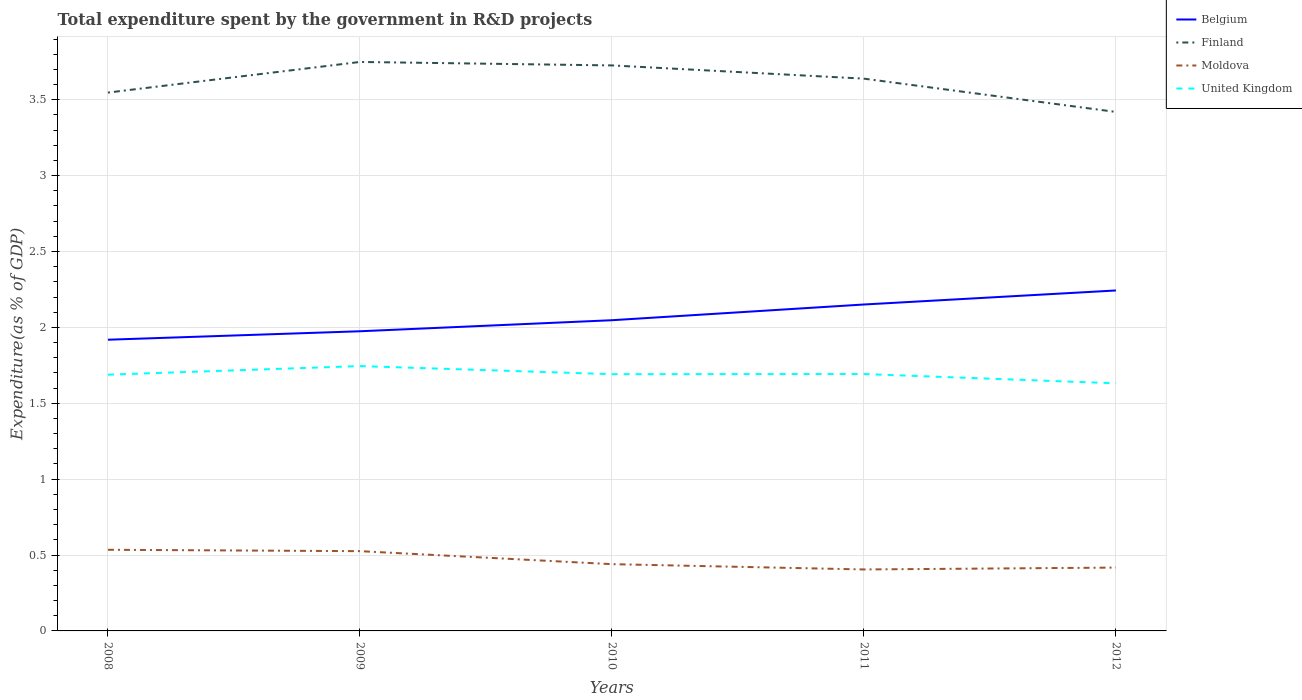How many different coloured lines are there?
Ensure brevity in your answer.  4. Across all years, what is the maximum total expenditure spent by the government in R&D projects in Moldova?
Keep it short and to the point. 0.4. What is the total total expenditure spent by the government in R&D projects in Belgium in the graph?
Offer a very short reply. -0.32. What is the difference between the highest and the second highest total expenditure spent by the government in R&D projects in United Kingdom?
Make the answer very short. 0.11. What is the difference between the highest and the lowest total expenditure spent by the government in R&D projects in Belgium?
Keep it short and to the point. 2. Does the graph contain grids?
Offer a terse response. Yes. Where does the legend appear in the graph?
Make the answer very short. Top right. How many legend labels are there?
Keep it short and to the point. 4. How are the legend labels stacked?
Offer a very short reply. Vertical. What is the title of the graph?
Your response must be concise. Total expenditure spent by the government in R&D projects. Does "Nigeria" appear as one of the legend labels in the graph?
Keep it short and to the point. No. What is the label or title of the Y-axis?
Provide a short and direct response. Expenditure(as % of GDP). What is the Expenditure(as % of GDP) of Belgium in 2008?
Your response must be concise. 1.92. What is the Expenditure(as % of GDP) of Finland in 2008?
Your answer should be compact. 3.55. What is the Expenditure(as % of GDP) of Moldova in 2008?
Ensure brevity in your answer.  0.53. What is the Expenditure(as % of GDP) of United Kingdom in 2008?
Make the answer very short. 1.69. What is the Expenditure(as % of GDP) of Belgium in 2009?
Your response must be concise. 1.97. What is the Expenditure(as % of GDP) of Finland in 2009?
Your answer should be very brief. 3.75. What is the Expenditure(as % of GDP) in Moldova in 2009?
Ensure brevity in your answer.  0.53. What is the Expenditure(as % of GDP) of United Kingdom in 2009?
Make the answer very short. 1.75. What is the Expenditure(as % of GDP) in Belgium in 2010?
Provide a succinct answer. 2.05. What is the Expenditure(as % of GDP) in Finland in 2010?
Keep it short and to the point. 3.73. What is the Expenditure(as % of GDP) in Moldova in 2010?
Make the answer very short. 0.44. What is the Expenditure(as % of GDP) in United Kingdom in 2010?
Ensure brevity in your answer.  1.69. What is the Expenditure(as % of GDP) of Belgium in 2011?
Offer a very short reply. 2.15. What is the Expenditure(as % of GDP) in Finland in 2011?
Provide a succinct answer. 3.64. What is the Expenditure(as % of GDP) in Moldova in 2011?
Your answer should be very brief. 0.4. What is the Expenditure(as % of GDP) in United Kingdom in 2011?
Your answer should be compact. 1.69. What is the Expenditure(as % of GDP) of Belgium in 2012?
Ensure brevity in your answer.  2.24. What is the Expenditure(as % of GDP) of Finland in 2012?
Keep it short and to the point. 3.42. What is the Expenditure(as % of GDP) in Moldova in 2012?
Provide a succinct answer. 0.42. What is the Expenditure(as % of GDP) in United Kingdom in 2012?
Your answer should be very brief. 1.63. Across all years, what is the maximum Expenditure(as % of GDP) in Belgium?
Offer a very short reply. 2.24. Across all years, what is the maximum Expenditure(as % of GDP) of Finland?
Your answer should be compact. 3.75. Across all years, what is the maximum Expenditure(as % of GDP) in Moldova?
Give a very brief answer. 0.53. Across all years, what is the maximum Expenditure(as % of GDP) in United Kingdom?
Provide a short and direct response. 1.75. Across all years, what is the minimum Expenditure(as % of GDP) of Belgium?
Ensure brevity in your answer.  1.92. Across all years, what is the minimum Expenditure(as % of GDP) of Finland?
Keep it short and to the point. 3.42. Across all years, what is the minimum Expenditure(as % of GDP) of Moldova?
Provide a short and direct response. 0.4. Across all years, what is the minimum Expenditure(as % of GDP) in United Kingdom?
Provide a succinct answer. 1.63. What is the total Expenditure(as % of GDP) of Belgium in the graph?
Your response must be concise. 10.33. What is the total Expenditure(as % of GDP) of Finland in the graph?
Make the answer very short. 18.08. What is the total Expenditure(as % of GDP) of Moldova in the graph?
Offer a terse response. 2.32. What is the total Expenditure(as % of GDP) in United Kingdom in the graph?
Your answer should be very brief. 8.45. What is the difference between the Expenditure(as % of GDP) of Belgium in 2008 and that in 2009?
Give a very brief answer. -0.06. What is the difference between the Expenditure(as % of GDP) of Finland in 2008 and that in 2009?
Give a very brief answer. -0.2. What is the difference between the Expenditure(as % of GDP) in Moldova in 2008 and that in 2009?
Keep it short and to the point. 0.01. What is the difference between the Expenditure(as % of GDP) of United Kingdom in 2008 and that in 2009?
Provide a short and direct response. -0.06. What is the difference between the Expenditure(as % of GDP) of Belgium in 2008 and that in 2010?
Make the answer very short. -0.13. What is the difference between the Expenditure(as % of GDP) of Finland in 2008 and that in 2010?
Provide a short and direct response. -0.18. What is the difference between the Expenditure(as % of GDP) of Moldova in 2008 and that in 2010?
Provide a short and direct response. 0.09. What is the difference between the Expenditure(as % of GDP) of United Kingdom in 2008 and that in 2010?
Provide a succinct answer. -0. What is the difference between the Expenditure(as % of GDP) of Belgium in 2008 and that in 2011?
Offer a terse response. -0.23. What is the difference between the Expenditure(as % of GDP) in Finland in 2008 and that in 2011?
Keep it short and to the point. -0.09. What is the difference between the Expenditure(as % of GDP) of Moldova in 2008 and that in 2011?
Your answer should be compact. 0.13. What is the difference between the Expenditure(as % of GDP) in United Kingdom in 2008 and that in 2011?
Provide a succinct answer. -0. What is the difference between the Expenditure(as % of GDP) of Belgium in 2008 and that in 2012?
Offer a terse response. -0.32. What is the difference between the Expenditure(as % of GDP) of Finland in 2008 and that in 2012?
Your answer should be compact. 0.13. What is the difference between the Expenditure(as % of GDP) of Moldova in 2008 and that in 2012?
Offer a very short reply. 0.12. What is the difference between the Expenditure(as % of GDP) in United Kingdom in 2008 and that in 2012?
Provide a short and direct response. 0.06. What is the difference between the Expenditure(as % of GDP) of Belgium in 2009 and that in 2010?
Provide a short and direct response. -0.07. What is the difference between the Expenditure(as % of GDP) in Finland in 2009 and that in 2010?
Provide a short and direct response. 0.02. What is the difference between the Expenditure(as % of GDP) of Moldova in 2009 and that in 2010?
Provide a short and direct response. 0.09. What is the difference between the Expenditure(as % of GDP) in United Kingdom in 2009 and that in 2010?
Provide a succinct answer. 0.05. What is the difference between the Expenditure(as % of GDP) in Belgium in 2009 and that in 2011?
Provide a succinct answer. -0.18. What is the difference between the Expenditure(as % of GDP) of Finland in 2009 and that in 2011?
Offer a terse response. 0.11. What is the difference between the Expenditure(as % of GDP) in Moldova in 2009 and that in 2011?
Provide a short and direct response. 0.12. What is the difference between the Expenditure(as % of GDP) of United Kingdom in 2009 and that in 2011?
Your answer should be compact. 0.05. What is the difference between the Expenditure(as % of GDP) of Belgium in 2009 and that in 2012?
Keep it short and to the point. -0.27. What is the difference between the Expenditure(as % of GDP) of Finland in 2009 and that in 2012?
Give a very brief answer. 0.33. What is the difference between the Expenditure(as % of GDP) of Moldova in 2009 and that in 2012?
Give a very brief answer. 0.11. What is the difference between the Expenditure(as % of GDP) in United Kingdom in 2009 and that in 2012?
Provide a succinct answer. 0.11. What is the difference between the Expenditure(as % of GDP) in Belgium in 2010 and that in 2011?
Your response must be concise. -0.1. What is the difference between the Expenditure(as % of GDP) in Finland in 2010 and that in 2011?
Provide a succinct answer. 0.09. What is the difference between the Expenditure(as % of GDP) in Moldova in 2010 and that in 2011?
Offer a very short reply. 0.03. What is the difference between the Expenditure(as % of GDP) in United Kingdom in 2010 and that in 2011?
Ensure brevity in your answer.  -0. What is the difference between the Expenditure(as % of GDP) in Belgium in 2010 and that in 2012?
Offer a very short reply. -0.2. What is the difference between the Expenditure(as % of GDP) of Finland in 2010 and that in 2012?
Provide a succinct answer. 0.31. What is the difference between the Expenditure(as % of GDP) of Moldova in 2010 and that in 2012?
Your response must be concise. 0.02. What is the difference between the Expenditure(as % of GDP) of United Kingdom in 2010 and that in 2012?
Keep it short and to the point. 0.06. What is the difference between the Expenditure(as % of GDP) of Belgium in 2011 and that in 2012?
Give a very brief answer. -0.09. What is the difference between the Expenditure(as % of GDP) in Finland in 2011 and that in 2012?
Provide a short and direct response. 0.22. What is the difference between the Expenditure(as % of GDP) in Moldova in 2011 and that in 2012?
Keep it short and to the point. -0.01. What is the difference between the Expenditure(as % of GDP) in United Kingdom in 2011 and that in 2012?
Your answer should be compact. 0.06. What is the difference between the Expenditure(as % of GDP) of Belgium in 2008 and the Expenditure(as % of GDP) of Finland in 2009?
Your answer should be compact. -1.83. What is the difference between the Expenditure(as % of GDP) of Belgium in 2008 and the Expenditure(as % of GDP) of Moldova in 2009?
Offer a very short reply. 1.39. What is the difference between the Expenditure(as % of GDP) of Belgium in 2008 and the Expenditure(as % of GDP) of United Kingdom in 2009?
Provide a succinct answer. 0.17. What is the difference between the Expenditure(as % of GDP) of Finland in 2008 and the Expenditure(as % of GDP) of Moldova in 2009?
Make the answer very short. 3.02. What is the difference between the Expenditure(as % of GDP) in Finland in 2008 and the Expenditure(as % of GDP) in United Kingdom in 2009?
Your answer should be compact. 1.8. What is the difference between the Expenditure(as % of GDP) of Moldova in 2008 and the Expenditure(as % of GDP) of United Kingdom in 2009?
Your answer should be compact. -1.21. What is the difference between the Expenditure(as % of GDP) of Belgium in 2008 and the Expenditure(as % of GDP) of Finland in 2010?
Offer a terse response. -1.81. What is the difference between the Expenditure(as % of GDP) of Belgium in 2008 and the Expenditure(as % of GDP) of Moldova in 2010?
Provide a succinct answer. 1.48. What is the difference between the Expenditure(as % of GDP) in Belgium in 2008 and the Expenditure(as % of GDP) in United Kingdom in 2010?
Offer a terse response. 0.23. What is the difference between the Expenditure(as % of GDP) of Finland in 2008 and the Expenditure(as % of GDP) of Moldova in 2010?
Provide a succinct answer. 3.11. What is the difference between the Expenditure(as % of GDP) in Finland in 2008 and the Expenditure(as % of GDP) in United Kingdom in 2010?
Offer a very short reply. 1.86. What is the difference between the Expenditure(as % of GDP) of Moldova in 2008 and the Expenditure(as % of GDP) of United Kingdom in 2010?
Provide a short and direct response. -1.16. What is the difference between the Expenditure(as % of GDP) of Belgium in 2008 and the Expenditure(as % of GDP) of Finland in 2011?
Your response must be concise. -1.72. What is the difference between the Expenditure(as % of GDP) of Belgium in 2008 and the Expenditure(as % of GDP) of Moldova in 2011?
Ensure brevity in your answer.  1.51. What is the difference between the Expenditure(as % of GDP) of Belgium in 2008 and the Expenditure(as % of GDP) of United Kingdom in 2011?
Offer a terse response. 0.23. What is the difference between the Expenditure(as % of GDP) of Finland in 2008 and the Expenditure(as % of GDP) of Moldova in 2011?
Keep it short and to the point. 3.14. What is the difference between the Expenditure(as % of GDP) of Finland in 2008 and the Expenditure(as % of GDP) of United Kingdom in 2011?
Offer a terse response. 1.85. What is the difference between the Expenditure(as % of GDP) of Moldova in 2008 and the Expenditure(as % of GDP) of United Kingdom in 2011?
Make the answer very short. -1.16. What is the difference between the Expenditure(as % of GDP) of Belgium in 2008 and the Expenditure(as % of GDP) of Finland in 2012?
Provide a short and direct response. -1.5. What is the difference between the Expenditure(as % of GDP) of Belgium in 2008 and the Expenditure(as % of GDP) of Moldova in 2012?
Your answer should be very brief. 1.5. What is the difference between the Expenditure(as % of GDP) in Belgium in 2008 and the Expenditure(as % of GDP) in United Kingdom in 2012?
Provide a short and direct response. 0.29. What is the difference between the Expenditure(as % of GDP) in Finland in 2008 and the Expenditure(as % of GDP) in Moldova in 2012?
Keep it short and to the point. 3.13. What is the difference between the Expenditure(as % of GDP) in Finland in 2008 and the Expenditure(as % of GDP) in United Kingdom in 2012?
Keep it short and to the point. 1.92. What is the difference between the Expenditure(as % of GDP) of Moldova in 2008 and the Expenditure(as % of GDP) of United Kingdom in 2012?
Your answer should be very brief. -1.1. What is the difference between the Expenditure(as % of GDP) of Belgium in 2009 and the Expenditure(as % of GDP) of Finland in 2010?
Your answer should be very brief. -1.75. What is the difference between the Expenditure(as % of GDP) in Belgium in 2009 and the Expenditure(as % of GDP) in Moldova in 2010?
Your answer should be very brief. 1.53. What is the difference between the Expenditure(as % of GDP) in Belgium in 2009 and the Expenditure(as % of GDP) in United Kingdom in 2010?
Your answer should be very brief. 0.28. What is the difference between the Expenditure(as % of GDP) of Finland in 2009 and the Expenditure(as % of GDP) of Moldova in 2010?
Your answer should be very brief. 3.31. What is the difference between the Expenditure(as % of GDP) in Finland in 2009 and the Expenditure(as % of GDP) in United Kingdom in 2010?
Offer a very short reply. 2.06. What is the difference between the Expenditure(as % of GDP) of Moldova in 2009 and the Expenditure(as % of GDP) of United Kingdom in 2010?
Provide a short and direct response. -1.17. What is the difference between the Expenditure(as % of GDP) of Belgium in 2009 and the Expenditure(as % of GDP) of Finland in 2011?
Your response must be concise. -1.66. What is the difference between the Expenditure(as % of GDP) of Belgium in 2009 and the Expenditure(as % of GDP) of Moldova in 2011?
Ensure brevity in your answer.  1.57. What is the difference between the Expenditure(as % of GDP) of Belgium in 2009 and the Expenditure(as % of GDP) of United Kingdom in 2011?
Your answer should be very brief. 0.28. What is the difference between the Expenditure(as % of GDP) in Finland in 2009 and the Expenditure(as % of GDP) in Moldova in 2011?
Make the answer very short. 3.34. What is the difference between the Expenditure(as % of GDP) of Finland in 2009 and the Expenditure(as % of GDP) of United Kingdom in 2011?
Your response must be concise. 2.06. What is the difference between the Expenditure(as % of GDP) of Moldova in 2009 and the Expenditure(as % of GDP) of United Kingdom in 2011?
Provide a short and direct response. -1.17. What is the difference between the Expenditure(as % of GDP) of Belgium in 2009 and the Expenditure(as % of GDP) of Finland in 2012?
Offer a terse response. -1.45. What is the difference between the Expenditure(as % of GDP) of Belgium in 2009 and the Expenditure(as % of GDP) of Moldova in 2012?
Provide a succinct answer. 1.56. What is the difference between the Expenditure(as % of GDP) of Belgium in 2009 and the Expenditure(as % of GDP) of United Kingdom in 2012?
Ensure brevity in your answer.  0.34. What is the difference between the Expenditure(as % of GDP) of Finland in 2009 and the Expenditure(as % of GDP) of Moldova in 2012?
Ensure brevity in your answer.  3.33. What is the difference between the Expenditure(as % of GDP) in Finland in 2009 and the Expenditure(as % of GDP) in United Kingdom in 2012?
Provide a short and direct response. 2.12. What is the difference between the Expenditure(as % of GDP) of Moldova in 2009 and the Expenditure(as % of GDP) of United Kingdom in 2012?
Your response must be concise. -1.11. What is the difference between the Expenditure(as % of GDP) of Belgium in 2010 and the Expenditure(as % of GDP) of Finland in 2011?
Offer a very short reply. -1.59. What is the difference between the Expenditure(as % of GDP) of Belgium in 2010 and the Expenditure(as % of GDP) of Moldova in 2011?
Keep it short and to the point. 1.64. What is the difference between the Expenditure(as % of GDP) of Belgium in 2010 and the Expenditure(as % of GDP) of United Kingdom in 2011?
Give a very brief answer. 0.35. What is the difference between the Expenditure(as % of GDP) of Finland in 2010 and the Expenditure(as % of GDP) of Moldova in 2011?
Provide a short and direct response. 3.32. What is the difference between the Expenditure(as % of GDP) of Finland in 2010 and the Expenditure(as % of GDP) of United Kingdom in 2011?
Give a very brief answer. 2.03. What is the difference between the Expenditure(as % of GDP) of Moldova in 2010 and the Expenditure(as % of GDP) of United Kingdom in 2011?
Ensure brevity in your answer.  -1.25. What is the difference between the Expenditure(as % of GDP) in Belgium in 2010 and the Expenditure(as % of GDP) in Finland in 2012?
Your answer should be compact. -1.37. What is the difference between the Expenditure(as % of GDP) in Belgium in 2010 and the Expenditure(as % of GDP) in Moldova in 2012?
Your response must be concise. 1.63. What is the difference between the Expenditure(as % of GDP) of Belgium in 2010 and the Expenditure(as % of GDP) of United Kingdom in 2012?
Ensure brevity in your answer.  0.42. What is the difference between the Expenditure(as % of GDP) in Finland in 2010 and the Expenditure(as % of GDP) in Moldova in 2012?
Offer a terse response. 3.31. What is the difference between the Expenditure(as % of GDP) in Finland in 2010 and the Expenditure(as % of GDP) in United Kingdom in 2012?
Your response must be concise. 2.09. What is the difference between the Expenditure(as % of GDP) of Moldova in 2010 and the Expenditure(as % of GDP) of United Kingdom in 2012?
Offer a very short reply. -1.19. What is the difference between the Expenditure(as % of GDP) of Belgium in 2011 and the Expenditure(as % of GDP) of Finland in 2012?
Your answer should be compact. -1.27. What is the difference between the Expenditure(as % of GDP) in Belgium in 2011 and the Expenditure(as % of GDP) in Moldova in 2012?
Your response must be concise. 1.73. What is the difference between the Expenditure(as % of GDP) of Belgium in 2011 and the Expenditure(as % of GDP) of United Kingdom in 2012?
Your response must be concise. 0.52. What is the difference between the Expenditure(as % of GDP) of Finland in 2011 and the Expenditure(as % of GDP) of Moldova in 2012?
Provide a succinct answer. 3.22. What is the difference between the Expenditure(as % of GDP) in Finland in 2011 and the Expenditure(as % of GDP) in United Kingdom in 2012?
Give a very brief answer. 2.01. What is the difference between the Expenditure(as % of GDP) of Moldova in 2011 and the Expenditure(as % of GDP) of United Kingdom in 2012?
Your answer should be very brief. -1.23. What is the average Expenditure(as % of GDP) of Belgium per year?
Your response must be concise. 2.07. What is the average Expenditure(as % of GDP) in Finland per year?
Give a very brief answer. 3.62. What is the average Expenditure(as % of GDP) in Moldova per year?
Your response must be concise. 0.46. What is the average Expenditure(as % of GDP) in United Kingdom per year?
Make the answer very short. 1.69. In the year 2008, what is the difference between the Expenditure(as % of GDP) of Belgium and Expenditure(as % of GDP) of Finland?
Ensure brevity in your answer.  -1.63. In the year 2008, what is the difference between the Expenditure(as % of GDP) in Belgium and Expenditure(as % of GDP) in Moldova?
Your answer should be compact. 1.38. In the year 2008, what is the difference between the Expenditure(as % of GDP) in Belgium and Expenditure(as % of GDP) in United Kingdom?
Your answer should be very brief. 0.23. In the year 2008, what is the difference between the Expenditure(as % of GDP) of Finland and Expenditure(as % of GDP) of Moldova?
Your answer should be very brief. 3.01. In the year 2008, what is the difference between the Expenditure(as % of GDP) in Finland and Expenditure(as % of GDP) in United Kingdom?
Your answer should be compact. 1.86. In the year 2008, what is the difference between the Expenditure(as % of GDP) in Moldova and Expenditure(as % of GDP) in United Kingdom?
Provide a short and direct response. -1.15. In the year 2009, what is the difference between the Expenditure(as % of GDP) in Belgium and Expenditure(as % of GDP) in Finland?
Ensure brevity in your answer.  -1.77. In the year 2009, what is the difference between the Expenditure(as % of GDP) of Belgium and Expenditure(as % of GDP) of Moldova?
Your answer should be compact. 1.45. In the year 2009, what is the difference between the Expenditure(as % of GDP) in Belgium and Expenditure(as % of GDP) in United Kingdom?
Offer a very short reply. 0.23. In the year 2009, what is the difference between the Expenditure(as % of GDP) of Finland and Expenditure(as % of GDP) of Moldova?
Keep it short and to the point. 3.22. In the year 2009, what is the difference between the Expenditure(as % of GDP) of Finland and Expenditure(as % of GDP) of United Kingdom?
Your answer should be very brief. 2. In the year 2009, what is the difference between the Expenditure(as % of GDP) in Moldova and Expenditure(as % of GDP) in United Kingdom?
Provide a succinct answer. -1.22. In the year 2010, what is the difference between the Expenditure(as % of GDP) in Belgium and Expenditure(as % of GDP) in Finland?
Your response must be concise. -1.68. In the year 2010, what is the difference between the Expenditure(as % of GDP) of Belgium and Expenditure(as % of GDP) of Moldova?
Your answer should be compact. 1.61. In the year 2010, what is the difference between the Expenditure(as % of GDP) in Belgium and Expenditure(as % of GDP) in United Kingdom?
Offer a terse response. 0.36. In the year 2010, what is the difference between the Expenditure(as % of GDP) of Finland and Expenditure(as % of GDP) of Moldova?
Your response must be concise. 3.29. In the year 2010, what is the difference between the Expenditure(as % of GDP) in Finland and Expenditure(as % of GDP) in United Kingdom?
Your answer should be very brief. 2.03. In the year 2010, what is the difference between the Expenditure(as % of GDP) in Moldova and Expenditure(as % of GDP) in United Kingdom?
Your answer should be very brief. -1.25. In the year 2011, what is the difference between the Expenditure(as % of GDP) in Belgium and Expenditure(as % of GDP) in Finland?
Keep it short and to the point. -1.49. In the year 2011, what is the difference between the Expenditure(as % of GDP) in Belgium and Expenditure(as % of GDP) in Moldova?
Ensure brevity in your answer.  1.75. In the year 2011, what is the difference between the Expenditure(as % of GDP) in Belgium and Expenditure(as % of GDP) in United Kingdom?
Provide a short and direct response. 0.46. In the year 2011, what is the difference between the Expenditure(as % of GDP) of Finland and Expenditure(as % of GDP) of Moldova?
Your response must be concise. 3.23. In the year 2011, what is the difference between the Expenditure(as % of GDP) of Finland and Expenditure(as % of GDP) of United Kingdom?
Keep it short and to the point. 1.95. In the year 2011, what is the difference between the Expenditure(as % of GDP) of Moldova and Expenditure(as % of GDP) of United Kingdom?
Offer a very short reply. -1.29. In the year 2012, what is the difference between the Expenditure(as % of GDP) of Belgium and Expenditure(as % of GDP) of Finland?
Your answer should be compact. -1.18. In the year 2012, what is the difference between the Expenditure(as % of GDP) in Belgium and Expenditure(as % of GDP) in Moldova?
Your response must be concise. 1.83. In the year 2012, what is the difference between the Expenditure(as % of GDP) in Belgium and Expenditure(as % of GDP) in United Kingdom?
Offer a terse response. 0.61. In the year 2012, what is the difference between the Expenditure(as % of GDP) in Finland and Expenditure(as % of GDP) in Moldova?
Give a very brief answer. 3. In the year 2012, what is the difference between the Expenditure(as % of GDP) in Finland and Expenditure(as % of GDP) in United Kingdom?
Your answer should be very brief. 1.79. In the year 2012, what is the difference between the Expenditure(as % of GDP) in Moldova and Expenditure(as % of GDP) in United Kingdom?
Make the answer very short. -1.21. What is the ratio of the Expenditure(as % of GDP) in Belgium in 2008 to that in 2009?
Provide a short and direct response. 0.97. What is the ratio of the Expenditure(as % of GDP) of Finland in 2008 to that in 2009?
Provide a short and direct response. 0.95. What is the ratio of the Expenditure(as % of GDP) in Moldova in 2008 to that in 2009?
Offer a very short reply. 1.02. What is the ratio of the Expenditure(as % of GDP) of United Kingdom in 2008 to that in 2009?
Provide a short and direct response. 0.97. What is the ratio of the Expenditure(as % of GDP) of Belgium in 2008 to that in 2010?
Your answer should be very brief. 0.94. What is the ratio of the Expenditure(as % of GDP) of Moldova in 2008 to that in 2010?
Offer a very short reply. 1.22. What is the ratio of the Expenditure(as % of GDP) of Belgium in 2008 to that in 2011?
Offer a very short reply. 0.89. What is the ratio of the Expenditure(as % of GDP) in Finland in 2008 to that in 2011?
Your response must be concise. 0.97. What is the ratio of the Expenditure(as % of GDP) in Moldova in 2008 to that in 2011?
Ensure brevity in your answer.  1.32. What is the ratio of the Expenditure(as % of GDP) in Belgium in 2008 to that in 2012?
Your response must be concise. 0.86. What is the ratio of the Expenditure(as % of GDP) of Finland in 2008 to that in 2012?
Give a very brief answer. 1.04. What is the ratio of the Expenditure(as % of GDP) in Moldova in 2008 to that in 2012?
Provide a short and direct response. 1.28. What is the ratio of the Expenditure(as % of GDP) of United Kingdom in 2008 to that in 2012?
Keep it short and to the point. 1.03. What is the ratio of the Expenditure(as % of GDP) of Belgium in 2009 to that in 2010?
Offer a terse response. 0.96. What is the ratio of the Expenditure(as % of GDP) in Moldova in 2009 to that in 2010?
Keep it short and to the point. 1.19. What is the ratio of the Expenditure(as % of GDP) of United Kingdom in 2009 to that in 2010?
Your answer should be compact. 1.03. What is the ratio of the Expenditure(as % of GDP) in Belgium in 2009 to that in 2011?
Give a very brief answer. 0.92. What is the ratio of the Expenditure(as % of GDP) of Finland in 2009 to that in 2011?
Offer a terse response. 1.03. What is the ratio of the Expenditure(as % of GDP) of Moldova in 2009 to that in 2011?
Offer a very short reply. 1.3. What is the ratio of the Expenditure(as % of GDP) of United Kingdom in 2009 to that in 2011?
Your answer should be compact. 1.03. What is the ratio of the Expenditure(as % of GDP) of Belgium in 2009 to that in 2012?
Make the answer very short. 0.88. What is the ratio of the Expenditure(as % of GDP) in Finland in 2009 to that in 2012?
Provide a succinct answer. 1.1. What is the ratio of the Expenditure(as % of GDP) in Moldova in 2009 to that in 2012?
Make the answer very short. 1.26. What is the ratio of the Expenditure(as % of GDP) in United Kingdom in 2009 to that in 2012?
Provide a short and direct response. 1.07. What is the ratio of the Expenditure(as % of GDP) of Belgium in 2010 to that in 2011?
Your answer should be compact. 0.95. What is the ratio of the Expenditure(as % of GDP) in Moldova in 2010 to that in 2011?
Give a very brief answer. 1.09. What is the ratio of the Expenditure(as % of GDP) of Belgium in 2010 to that in 2012?
Your answer should be compact. 0.91. What is the ratio of the Expenditure(as % of GDP) in Finland in 2010 to that in 2012?
Offer a terse response. 1.09. What is the ratio of the Expenditure(as % of GDP) of Moldova in 2010 to that in 2012?
Offer a very short reply. 1.05. What is the ratio of the Expenditure(as % of GDP) of United Kingdom in 2010 to that in 2012?
Keep it short and to the point. 1.04. What is the ratio of the Expenditure(as % of GDP) of Belgium in 2011 to that in 2012?
Your answer should be very brief. 0.96. What is the ratio of the Expenditure(as % of GDP) in Finland in 2011 to that in 2012?
Your response must be concise. 1.06. What is the ratio of the Expenditure(as % of GDP) of Moldova in 2011 to that in 2012?
Ensure brevity in your answer.  0.97. What is the ratio of the Expenditure(as % of GDP) of United Kingdom in 2011 to that in 2012?
Your answer should be compact. 1.04. What is the difference between the highest and the second highest Expenditure(as % of GDP) in Belgium?
Your answer should be very brief. 0.09. What is the difference between the highest and the second highest Expenditure(as % of GDP) in Finland?
Provide a short and direct response. 0.02. What is the difference between the highest and the second highest Expenditure(as % of GDP) in Moldova?
Keep it short and to the point. 0.01. What is the difference between the highest and the second highest Expenditure(as % of GDP) of United Kingdom?
Ensure brevity in your answer.  0.05. What is the difference between the highest and the lowest Expenditure(as % of GDP) of Belgium?
Your response must be concise. 0.32. What is the difference between the highest and the lowest Expenditure(as % of GDP) in Finland?
Provide a succinct answer. 0.33. What is the difference between the highest and the lowest Expenditure(as % of GDP) in Moldova?
Give a very brief answer. 0.13. What is the difference between the highest and the lowest Expenditure(as % of GDP) of United Kingdom?
Your answer should be compact. 0.11. 